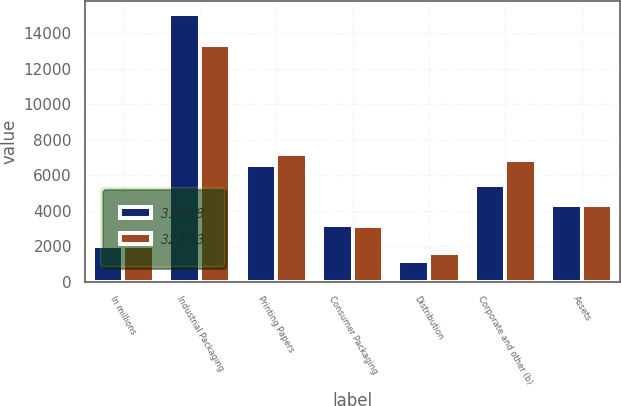<chart> <loc_0><loc_0><loc_500><loc_500><stacked_bar_chart><ecel><fcel>In millions<fcel>Industrial Packaging<fcel>Printing Papers<fcel>Consumer Packaging<fcel>Distribution<fcel>Corporate and other (b)<fcel>Assets<nl><fcel>31528<fcel>2013<fcel>15083<fcel>6574<fcel>3222<fcel>1186<fcel>5463<fcel>4342.5<nl><fcel>32153<fcel>2012<fcel>13353<fcel>7198<fcel>3123<fcel>1639<fcel>6840<fcel>4342.5<nl></chart> 